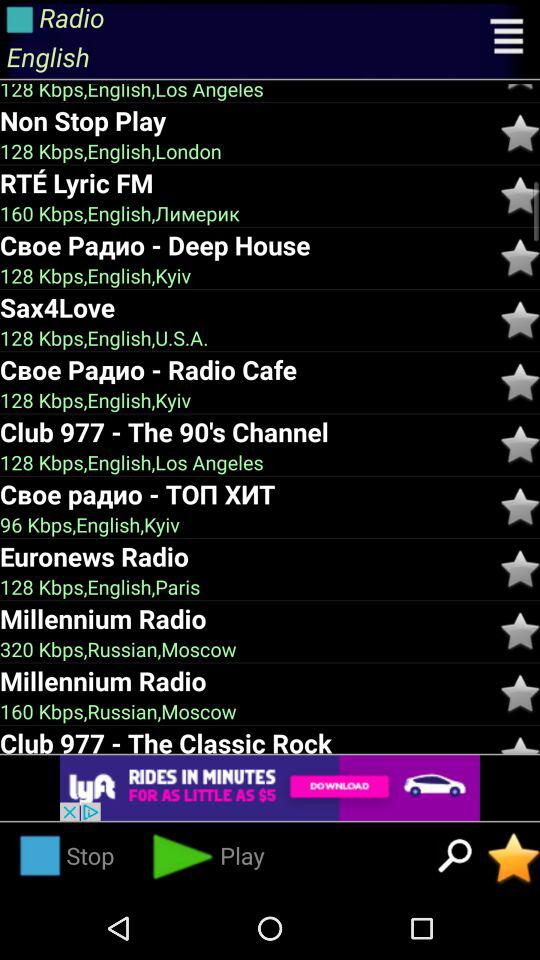In which language was "Euronews Radio" broadcast? The language is English. 